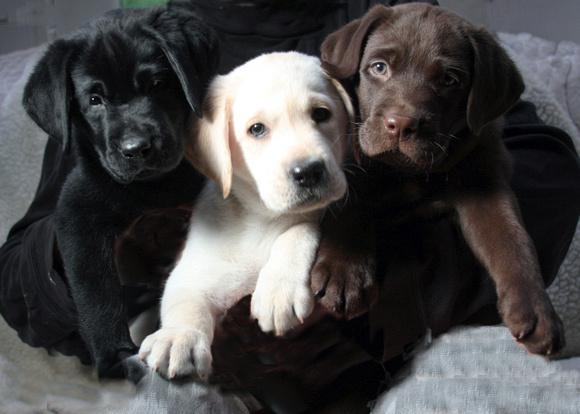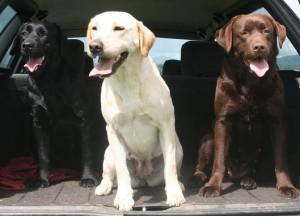The first image is the image on the left, the second image is the image on the right. Given the left and right images, does the statement "The right image has a black dog furthest to the left that is seated next to a white dog." hold true? Answer yes or no. Yes. The first image is the image on the left, the second image is the image on the right. For the images displayed, is the sentence "There is a white (or lighter-colored) dog sitting in between two darker colored dogs in each image" factually correct? Answer yes or no. Yes. 